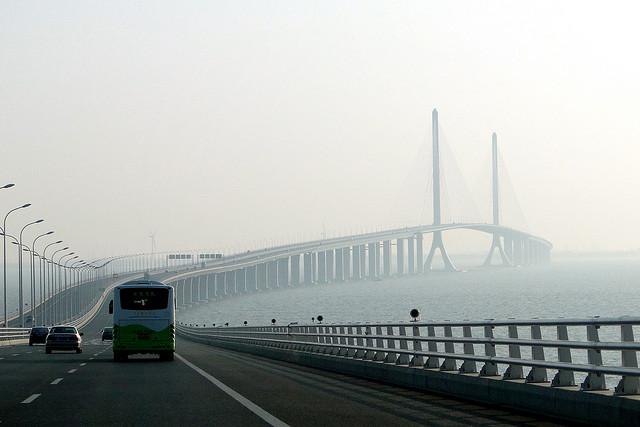<image>Why are there wires above the trains? It is ambiguous as to why there are wires above the trains, as it could be for electricity or for holding up a bridge. However, it's also possible that there are no wires or trains in the image. Why are there wires above the trains? I don't know why there are wires above the trains. It could be for electricity or holding up the bridge. 